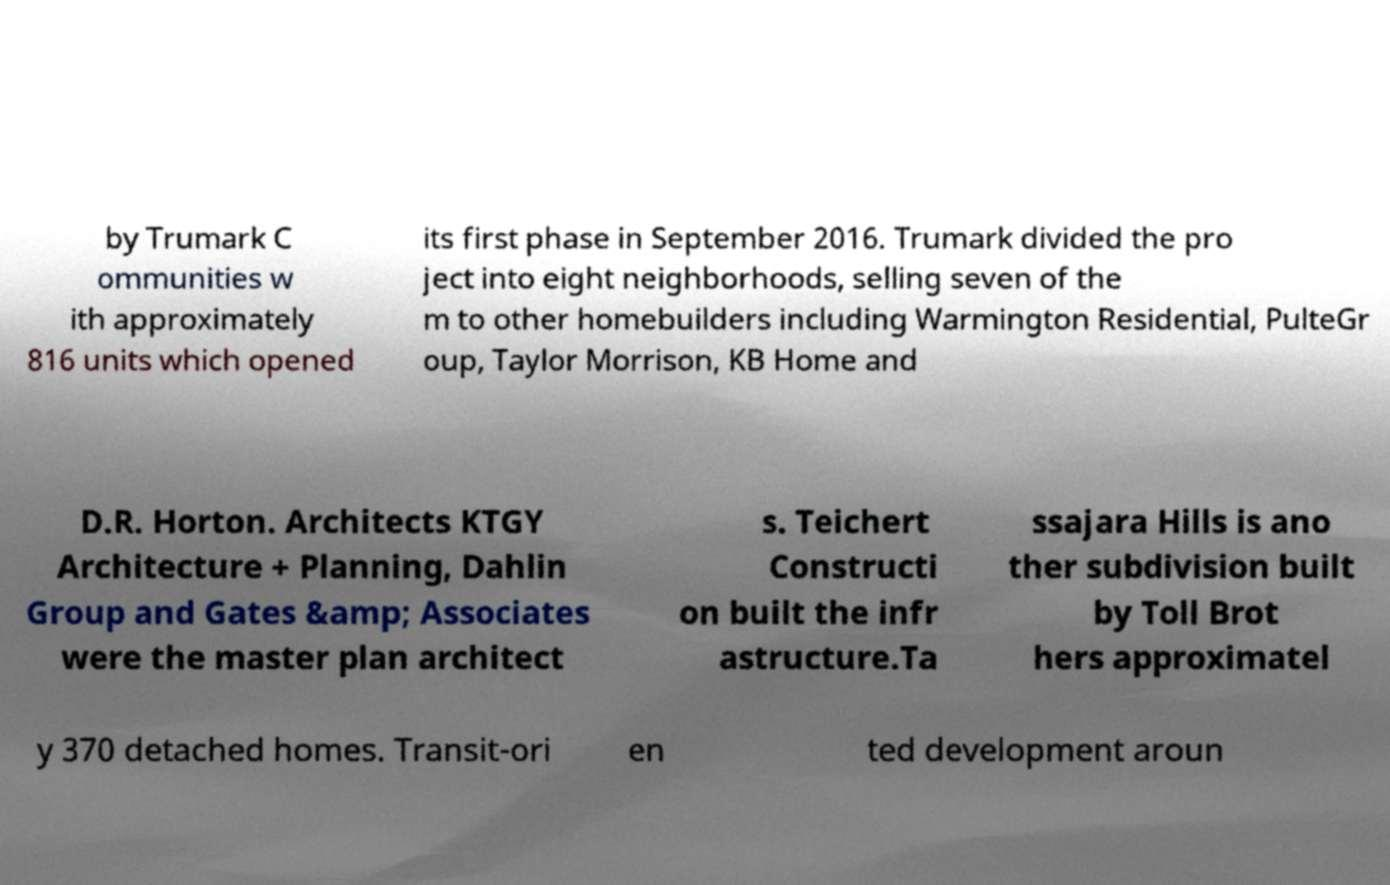Please read and relay the text visible in this image. What does it say? by Trumark C ommunities w ith approximately 816 units which opened its first phase in September 2016. Trumark divided the pro ject into eight neighborhoods, selling seven of the m to other homebuilders including Warmington Residential, PulteGr oup, Taylor Morrison, KB Home and D.R. Horton. Architects KTGY Architecture + Planning, Dahlin Group and Gates &amp; Associates were the master plan architect s. Teichert Constructi on built the infr astructure.Ta ssajara Hills is ano ther subdivision built by Toll Brot hers approximatel y 370 detached homes. Transit-ori en ted development aroun 